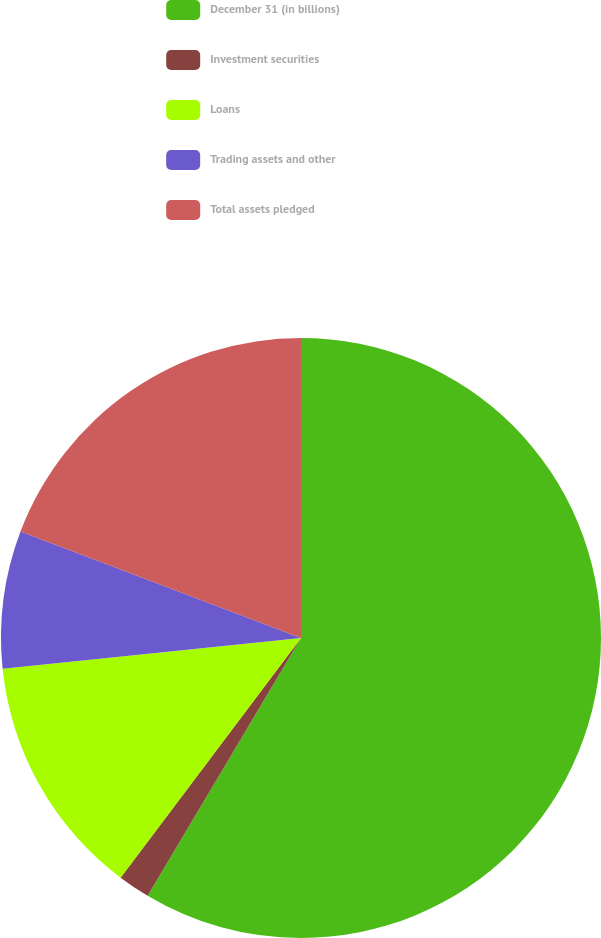Convert chart. <chart><loc_0><loc_0><loc_500><loc_500><pie_chart><fcel>December 31 (in billions)<fcel>Investment securities<fcel>Loans<fcel>Trading assets and other<fcel>Total assets pledged<nl><fcel>58.54%<fcel>1.73%<fcel>13.09%<fcel>7.41%<fcel>19.23%<nl></chart> 